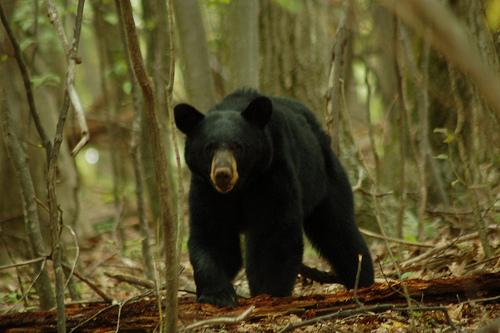What is the prominent animal in the image and what is its color? The prominent animal is a black bear. Provide a description of the ground surface in the image. The ground has brown twigs, crushed leaves, and a rotten log laying on it. What facial features of the bear are mentioned and what are their colors? The bear's nose is brown, eyes are black or brown, and it has a closed mouth. Describe any noticeable details about the bear's physical appearance. The bear has a big head, long curved claws, black eyes, a brown nose, shoulder muscle, and fur standing up on its back. What is the overall setting of the image? The setting is a forest with a black bear walking and interacting with its surroundings. 